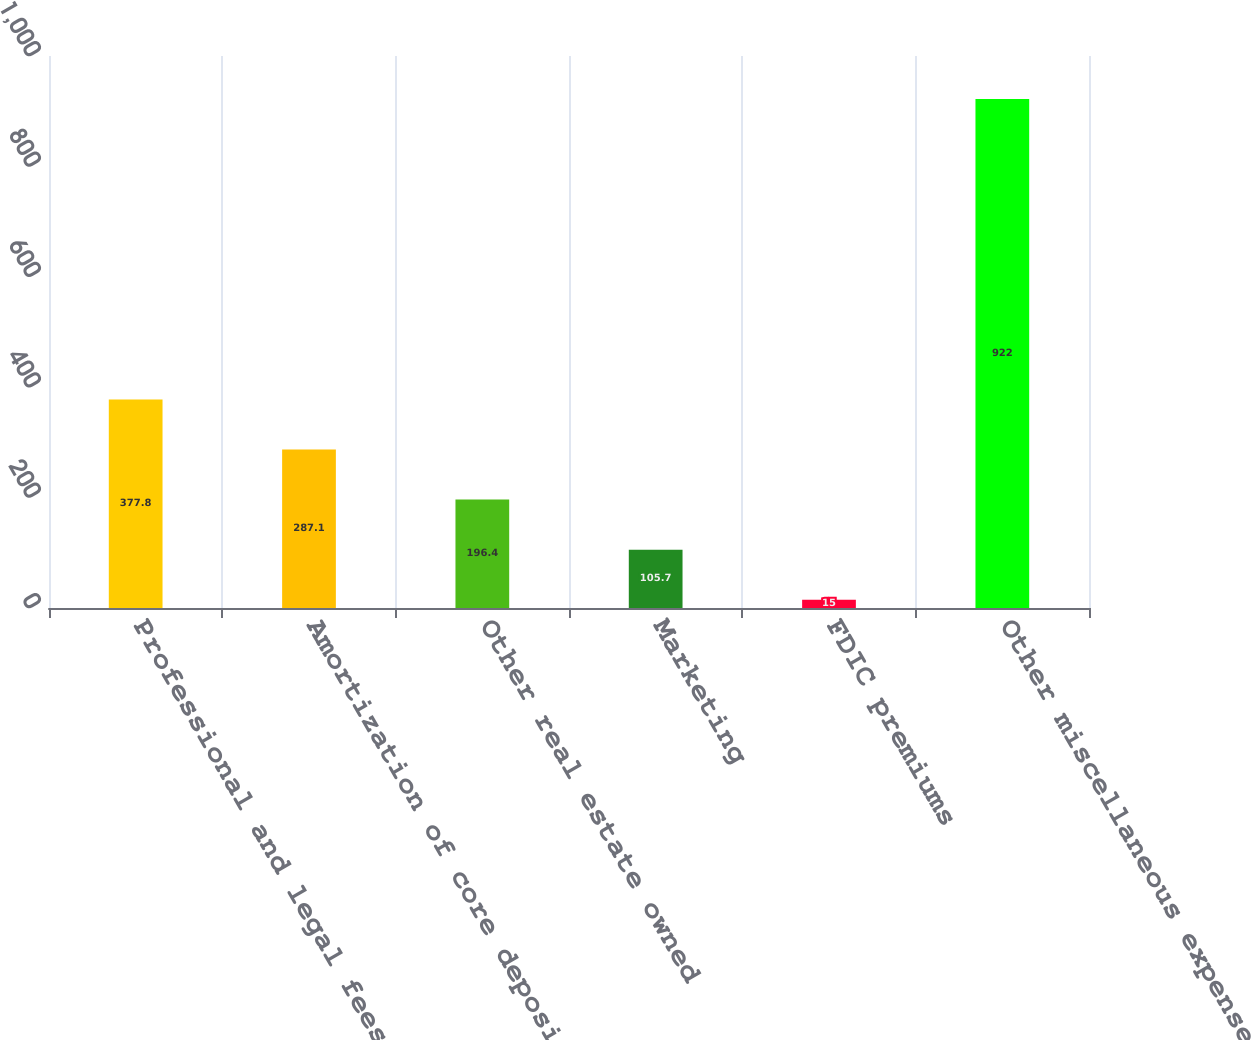<chart> <loc_0><loc_0><loc_500><loc_500><bar_chart><fcel>Professional and legal fees<fcel>Amortization of core deposit<fcel>Other real estate owned<fcel>Marketing<fcel>FDIC premiums<fcel>Other miscellaneous expenses<nl><fcel>377.8<fcel>287.1<fcel>196.4<fcel>105.7<fcel>15<fcel>922<nl></chart> 